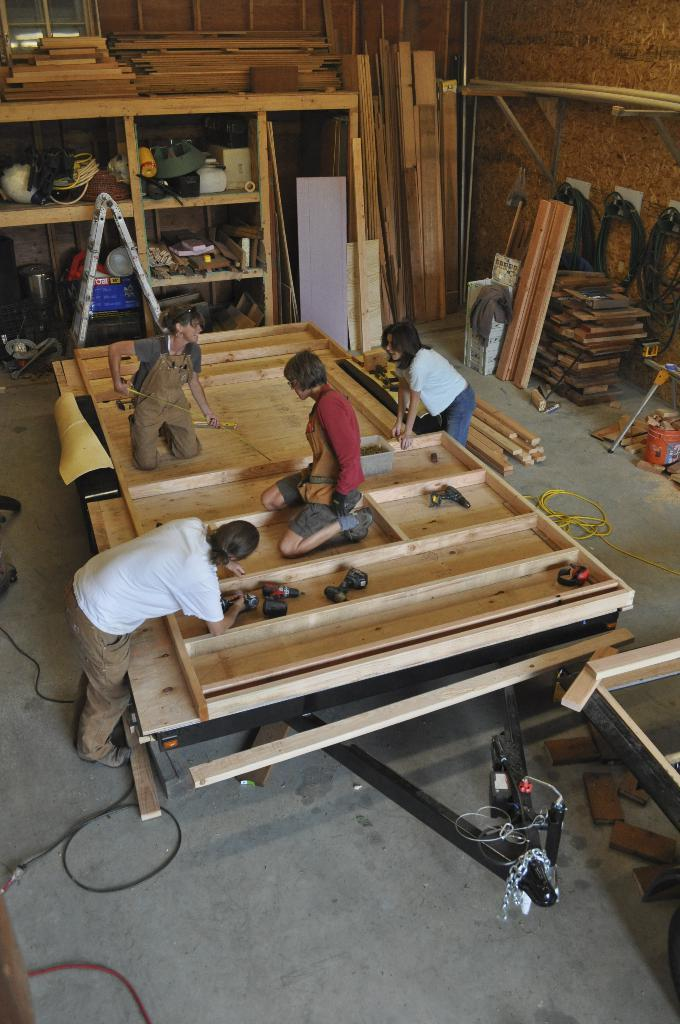What type of establishment is depicted in the image? There is a carpentry workshop in the image. What are the people inside the workshop doing? People are working inside the carpentry workshop. What type of picture is hanging on the wall in the carpentry workshop? There is no information about a picture hanging on the wall in the carpentry workshop. 